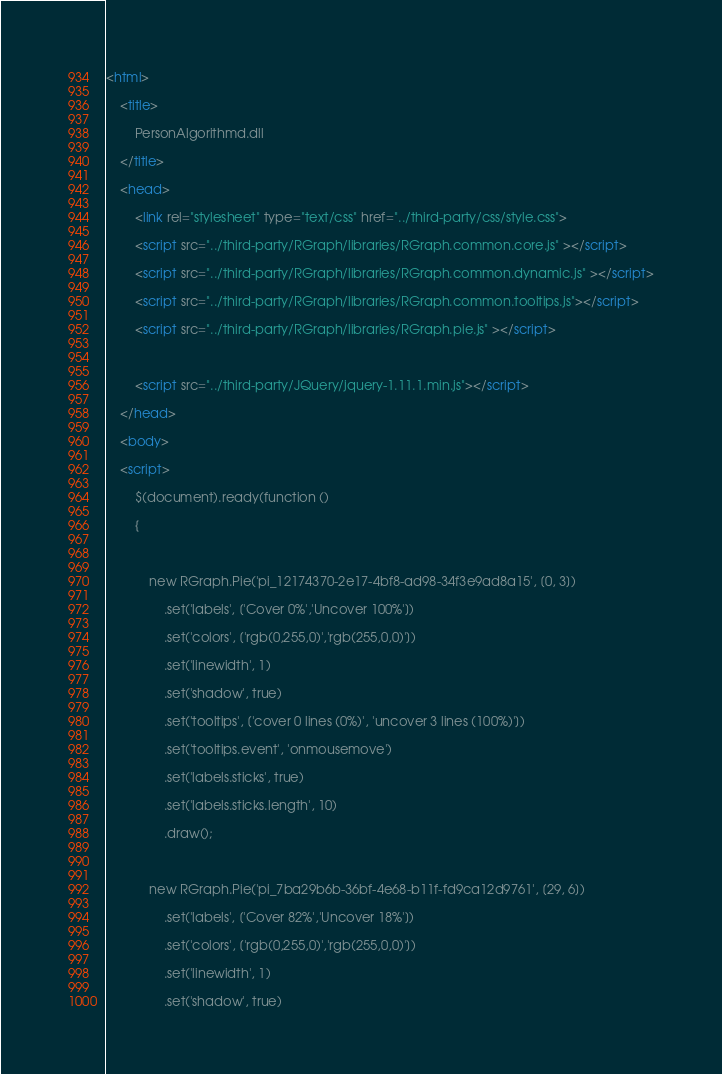Convert code to text. <code><loc_0><loc_0><loc_500><loc_500><_HTML_><html>
    <title>
        PersonAlgorithmd.dll
    </title>
    <head>
        <link rel="stylesheet" type="text/css" href="../third-party/css/style.css">
        <script src="../third-party/RGraph/libraries/RGraph.common.core.js" ></script>
        <script src="../third-party/RGraph/libraries/RGraph.common.dynamic.js" ></script>
        <script src="../third-party/RGraph/libraries/RGraph.common.tooltips.js"></script>
        <script src="../third-party/RGraph/libraries/RGraph.pie.js" ></script>

        <script src="../third-party/JQuery/jquery-1.11.1.min.js"></script>
    </head>
    <body>
    <script>
        $(document).ready(function ()
        {
            
            new RGraph.Pie('pi_12174370-2e17-4bf8-ad98-34f3e9ad8a15', [0, 3])
                .set('labels', ['Cover 0%','Uncover 100%'])
                .set('colors', ['rgb(0,255,0)','rgb(255,0,0)'])
                .set('linewidth', 1)
                .set('shadow', true)
                .set('tooltips', ['cover 0 lines (0%)', 'uncover 3 lines (100%)'])
                .set('tooltips.event', 'onmousemove')
                .set('labels.sticks', true)
                .set('labels.sticks.length', 10)
                .draw();
            
            new RGraph.Pie('pi_7ba29b6b-36bf-4e68-b11f-fd9ca12d9761', [29, 6])
                .set('labels', ['Cover 82%','Uncover 18%'])
                .set('colors', ['rgb(0,255,0)','rgb(255,0,0)'])
                .set('linewidth', 1)
                .set('shadow', true)</code> 